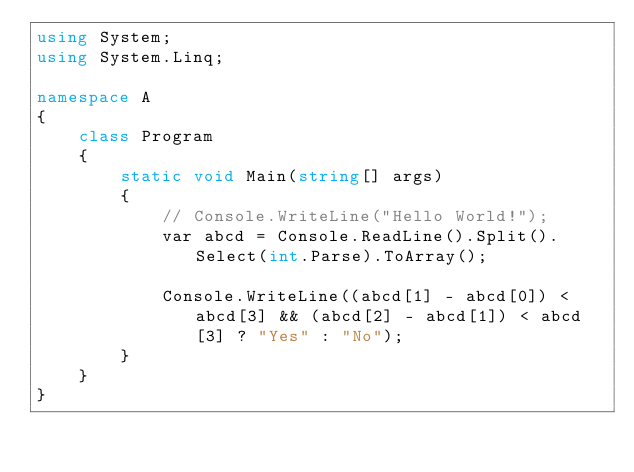<code> <loc_0><loc_0><loc_500><loc_500><_C#_>using System;
using System.Linq;

namespace A
{
    class Program
    {
        static void Main(string[] args)
        {
            // Console.WriteLine("Hello World!");
            var abcd = Console.ReadLine().Split().Select(int.Parse).ToArray();

            Console.WriteLine((abcd[1] - abcd[0]) < abcd[3] && (abcd[2] - abcd[1]) < abcd[3] ? "Yes" : "No");
        }
    }
}
</code> 